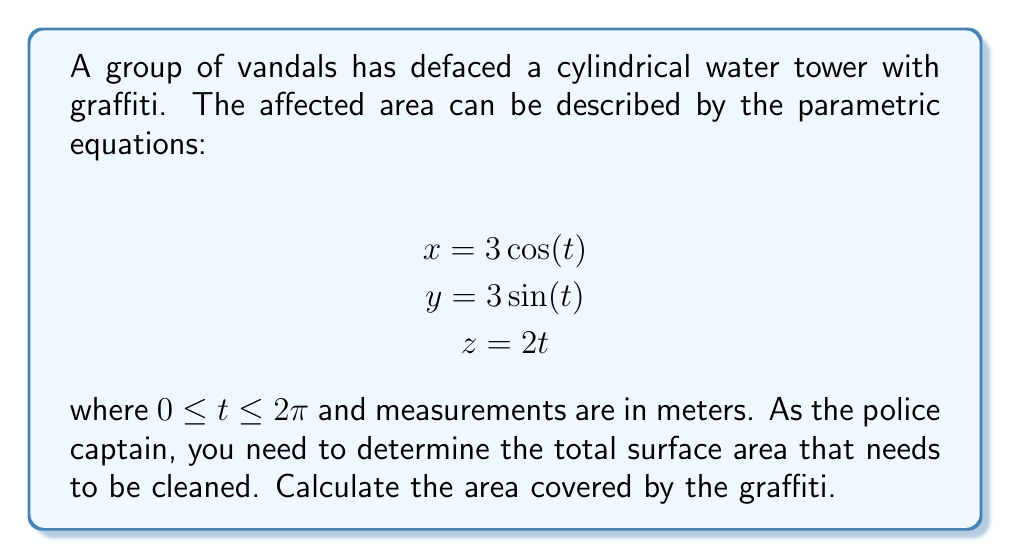Provide a solution to this math problem. To calculate the area covered by the graffiti, we need to use the surface area formula for parametric equations:

$$A = \int_a^b \sqrt{(\frac{dx}{dt})^2 + (\frac{dy}{dt})^2 + (\frac{dz}{dt})^2} dt$$

Let's follow these steps:

1) First, we need to find the derivatives:
   $$\frac{dx}{dt} = -3\sin(t)$$
   $$\frac{dy}{dt} = 3\cos(t)$$
   $$\frac{dz}{dt} = 2$$

2) Now, let's substitute these into our formula:
   $$A = \int_0^{2\pi} \sqrt{(-3\sin(t))^2 + (3\cos(t))^2 + 2^2} dt$$

3) Simplify under the square root:
   $$A = \int_0^{2\pi} \sqrt{9\sin^2(t) + 9\cos^2(t) + 4} dt$$

4) Recall that $\sin^2(t) + \cos^2(t) = 1$:
   $$A = \int_0^{2\pi} \sqrt{9(1) + 4} dt = \int_0^{2\pi} \sqrt{13} dt$$

5) $\sqrt{13}$ is a constant, so we can take it out of the integral:
   $$A = \sqrt{13} \int_0^{2\pi} dt$$

6) Integrate:
   $$A = \sqrt{13} [t]_0^{2\pi} = \sqrt{13} (2\pi - 0) = 2\pi\sqrt{13}$$

Therefore, the area covered by the graffiti is $2\pi\sqrt{13}$ square meters.
Answer: $2\pi\sqrt{13}$ square meters 